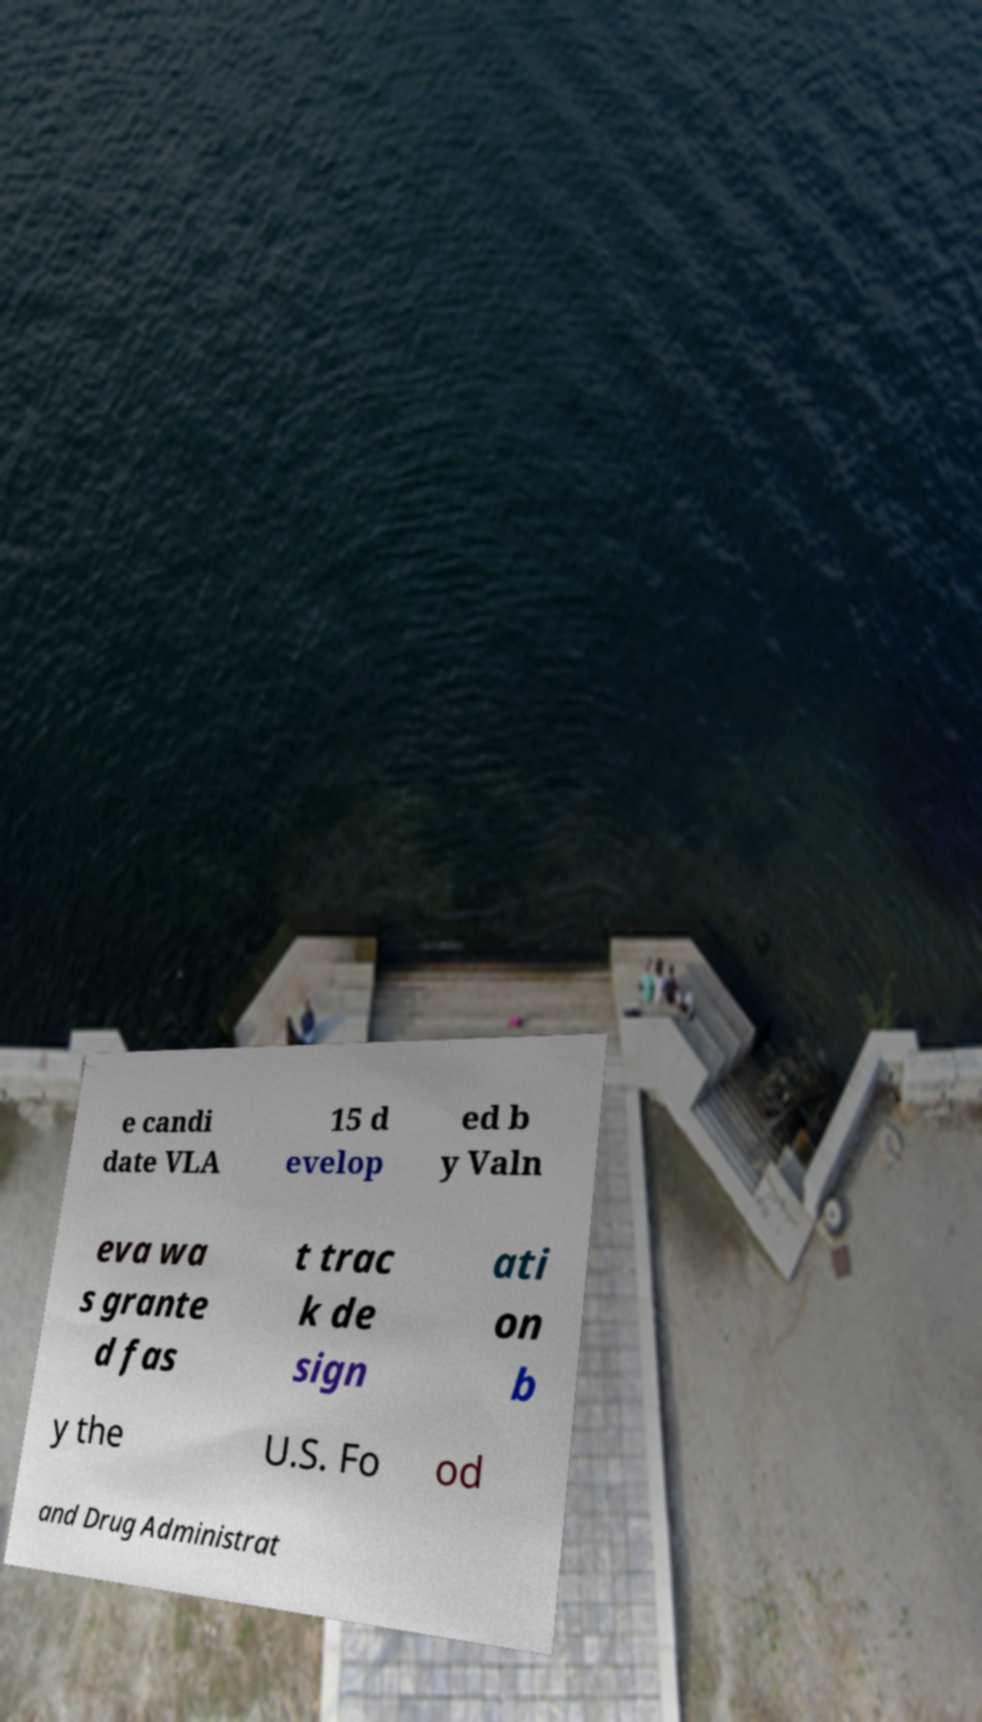For documentation purposes, I need the text within this image transcribed. Could you provide that? e candi date VLA 15 d evelop ed b y Valn eva wa s grante d fas t trac k de sign ati on b y the U.S. Fo od and Drug Administrat 